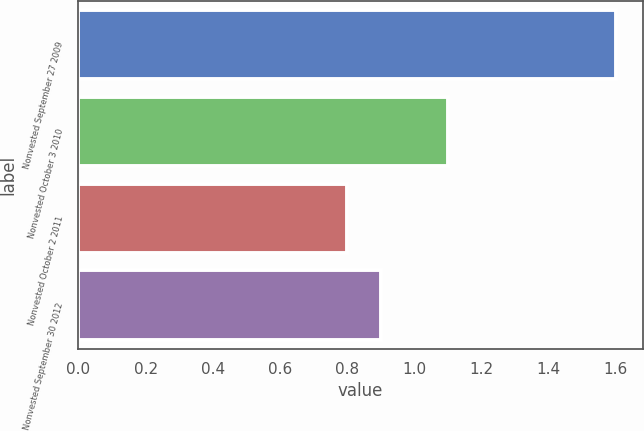Convert chart to OTSL. <chart><loc_0><loc_0><loc_500><loc_500><bar_chart><fcel>Nonvested September 27 2009<fcel>Nonvested October 3 2010<fcel>Nonvested October 2 2011<fcel>Nonvested September 30 2012<nl><fcel>1.6<fcel>1.1<fcel>0.8<fcel>0.9<nl></chart> 